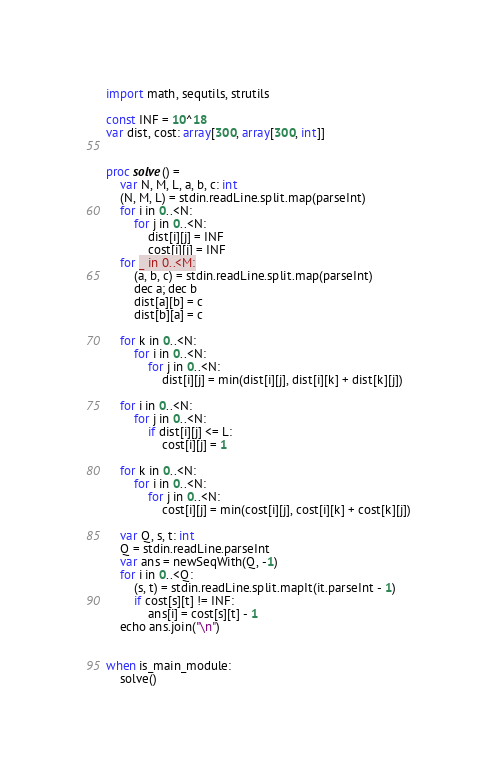<code> <loc_0><loc_0><loc_500><loc_500><_Nim_>import math, sequtils, strutils

const INF = 10^18
var dist, cost: array[300, array[300, int]]


proc solve() =
    var N, M, L, a, b, c: int
    (N, M, L) = stdin.readLine.split.map(parseInt)
    for i in 0..<N:
        for j in 0..<N:
            dist[i][j] = INF
            cost[i][j] = INF
    for _ in 0..<M:
        (a, b, c) = stdin.readLine.split.map(parseInt)
        dec a; dec b
        dist[a][b] = c
        dist[b][a] = c
    
    for k in 0..<N:
        for i in 0..<N:
            for j in 0..<N:
                dist[i][j] = min(dist[i][j], dist[i][k] + dist[k][j])
    
    for i in 0..<N:
        for j in 0..<N:
            if dist[i][j] <= L:
                cost[i][j] = 1
    
    for k in 0..<N:
        for i in 0..<N:
            for j in 0..<N:
                cost[i][j] = min(cost[i][j], cost[i][k] + cost[k][j])
    
    var Q, s, t: int
    Q = stdin.readLine.parseInt
    var ans = newSeqWith(Q, -1)
    for i in 0..<Q:
        (s, t) = stdin.readLine.split.mapIt(it.parseInt - 1)
        if cost[s][t] != INF:
            ans[i] = cost[s][t] - 1
    echo ans.join("\n")


when is_main_module:
    solve()
</code> 